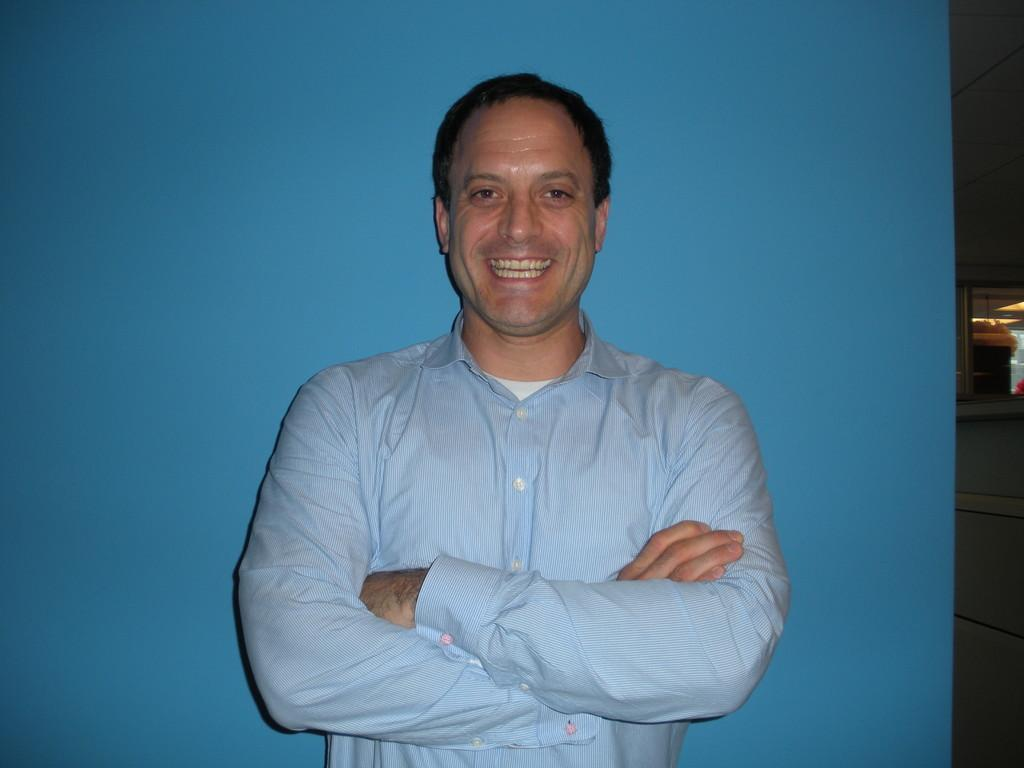What is the main subject of the image? There is a person standing in the center of the image. What is the person's expression in the image? The person is smiling in the image. What can be seen in the background of the image? There is a wall and a window visible in the background. What type of corn is being used as a decoration in the image? There is no corn present in the image. What valuable jewel can be seen on the person's neck in the image? There is no jewel visible on the person's neck in the image. 